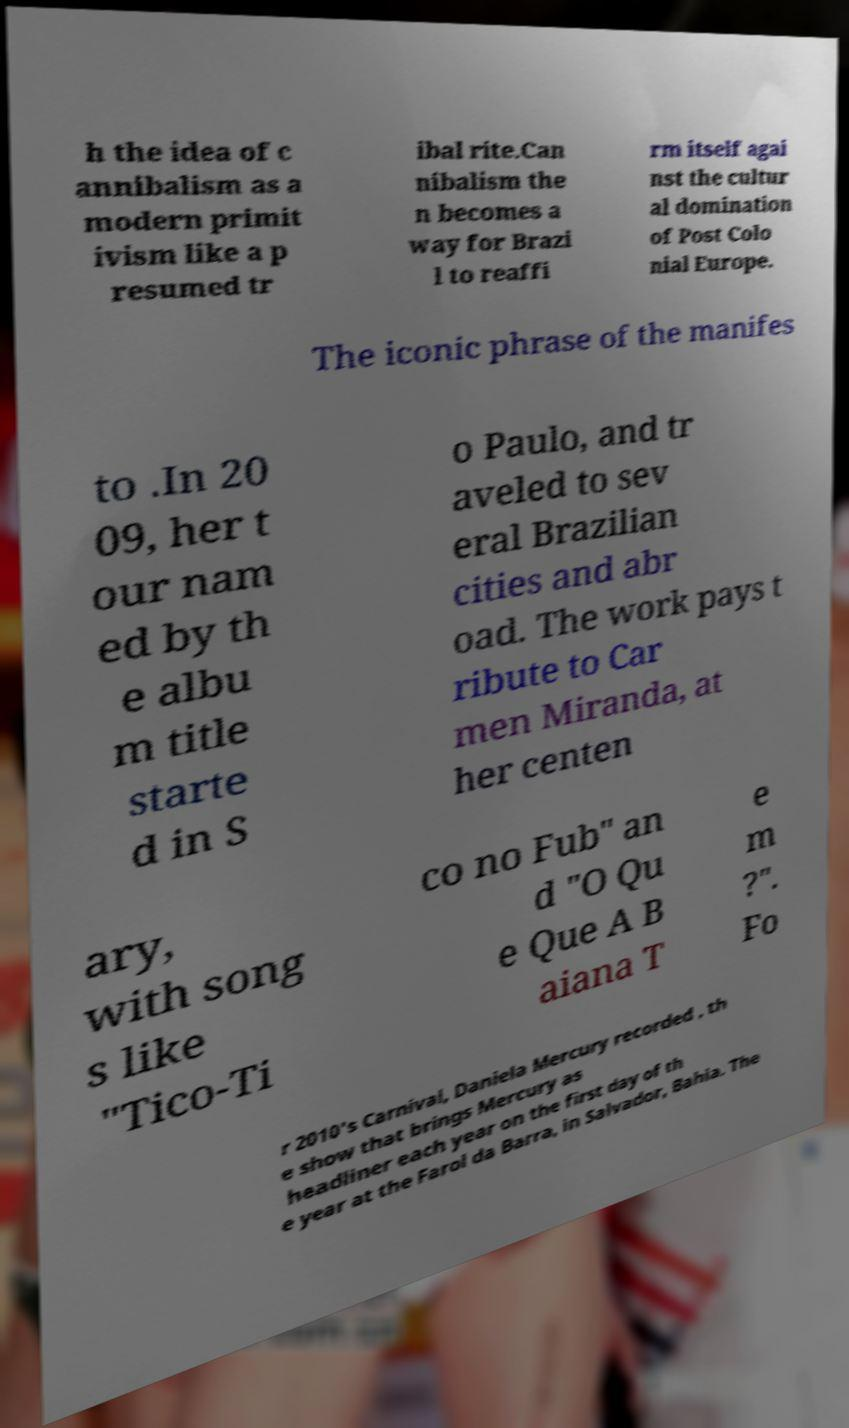Can you read and provide the text displayed in the image?This photo seems to have some interesting text. Can you extract and type it out for me? h the idea of c annibalism as a modern primit ivism like a p resumed tr ibal rite.Can nibalism the n becomes a way for Brazi l to reaffi rm itself agai nst the cultur al domination of Post Colo nial Europe. The iconic phrase of the manifes to .In 20 09, her t our nam ed by th e albu m title starte d in S o Paulo, and tr aveled to sev eral Brazilian cities and abr oad. The work pays t ribute to Car men Miranda, at her centen ary, with song s like "Tico-Ti co no Fub" an d "O Qu e Que A B aiana T e m ?". Fo r 2010's Carnival, Daniela Mercury recorded , th e show that brings Mercury as headliner each year on the first day of th e year at the Farol da Barra, in Salvador, Bahia. The 